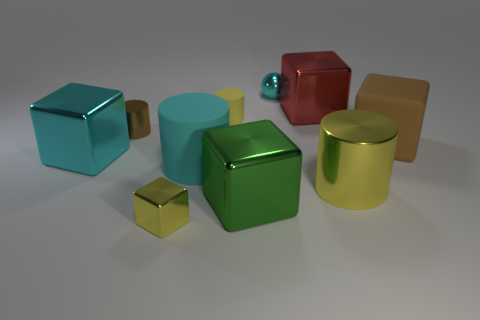Subtract 1 cylinders. How many cylinders are left? 3 Subtract all purple cubes. Subtract all brown cylinders. How many cubes are left? 5 Subtract all spheres. How many objects are left? 9 Subtract all large brown cubes. Subtract all large red metallic cubes. How many objects are left? 8 Add 2 small yellow cylinders. How many small yellow cylinders are left? 3 Add 4 red objects. How many red objects exist? 5 Subtract 0 green balls. How many objects are left? 10 